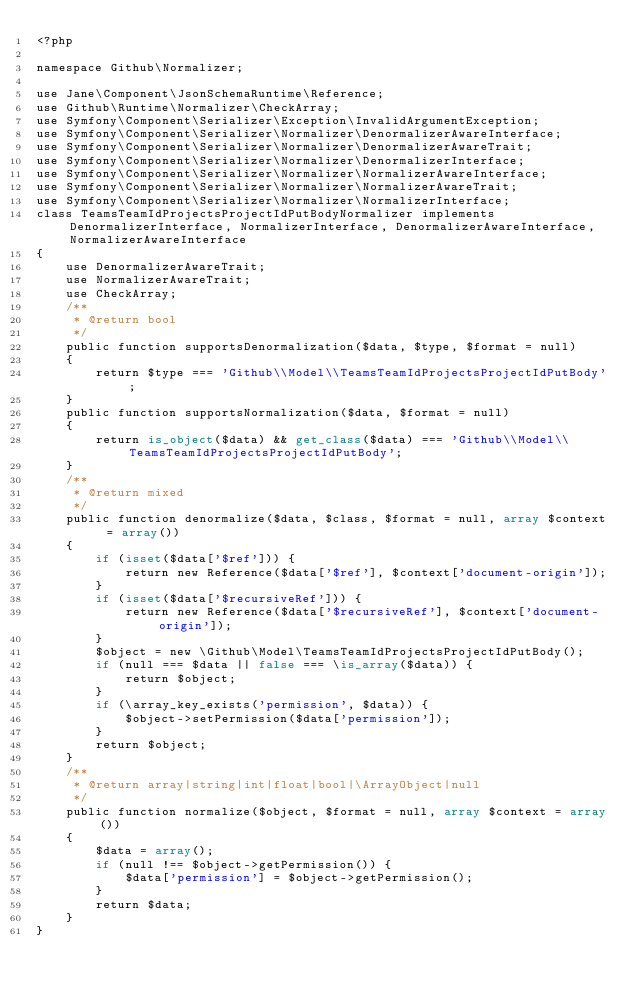Convert code to text. <code><loc_0><loc_0><loc_500><loc_500><_PHP_><?php

namespace Github\Normalizer;

use Jane\Component\JsonSchemaRuntime\Reference;
use Github\Runtime\Normalizer\CheckArray;
use Symfony\Component\Serializer\Exception\InvalidArgumentException;
use Symfony\Component\Serializer\Normalizer\DenormalizerAwareInterface;
use Symfony\Component\Serializer\Normalizer\DenormalizerAwareTrait;
use Symfony\Component\Serializer\Normalizer\DenormalizerInterface;
use Symfony\Component\Serializer\Normalizer\NormalizerAwareInterface;
use Symfony\Component\Serializer\Normalizer\NormalizerAwareTrait;
use Symfony\Component\Serializer\Normalizer\NormalizerInterface;
class TeamsTeamIdProjectsProjectIdPutBodyNormalizer implements DenormalizerInterface, NormalizerInterface, DenormalizerAwareInterface, NormalizerAwareInterface
{
    use DenormalizerAwareTrait;
    use NormalizerAwareTrait;
    use CheckArray;
    /**
     * @return bool
     */
    public function supportsDenormalization($data, $type, $format = null)
    {
        return $type === 'Github\\Model\\TeamsTeamIdProjectsProjectIdPutBody';
    }
    public function supportsNormalization($data, $format = null)
    {
        return is_object($data) && get_class($data) === 'Github\\Model\\TeamsTeamIdProjectsProjectIdPutBody';
    }
    /**
     * @return mixed
     */
    public function denormalize($data, $class, $format = null, array $context = array())
    {
        if (isset($data['$ref'])) {
            return new Reference($data['$ref'], $context['document-origin']);
        }
        if (isset($data['$recursiveRef'])) {
            return new Reference($data['$recursiveRef'], $context['document-origin']);
        }
        $object = new \Github\Model\TeamsTeamIdProjectsProjectIdPutBody();
        if (null === $data || false === \is_array($data)) {
            return $object;
        }
        if (\array_key_exists('permission', $data)) {
            $object->setPermission($data['permission']);
        }
        return $object;
    }
    /**
     * @return array|string|int|float|bool|\ArrayObject|null
     */
    public function normalize($object, $format = null, array $context = array())
    {
        $data = array();
        if (null !== $object->getPermission()) {
            $data['permission'] = $object->getPermission();
        }
        return $data;
    }
}</code> 